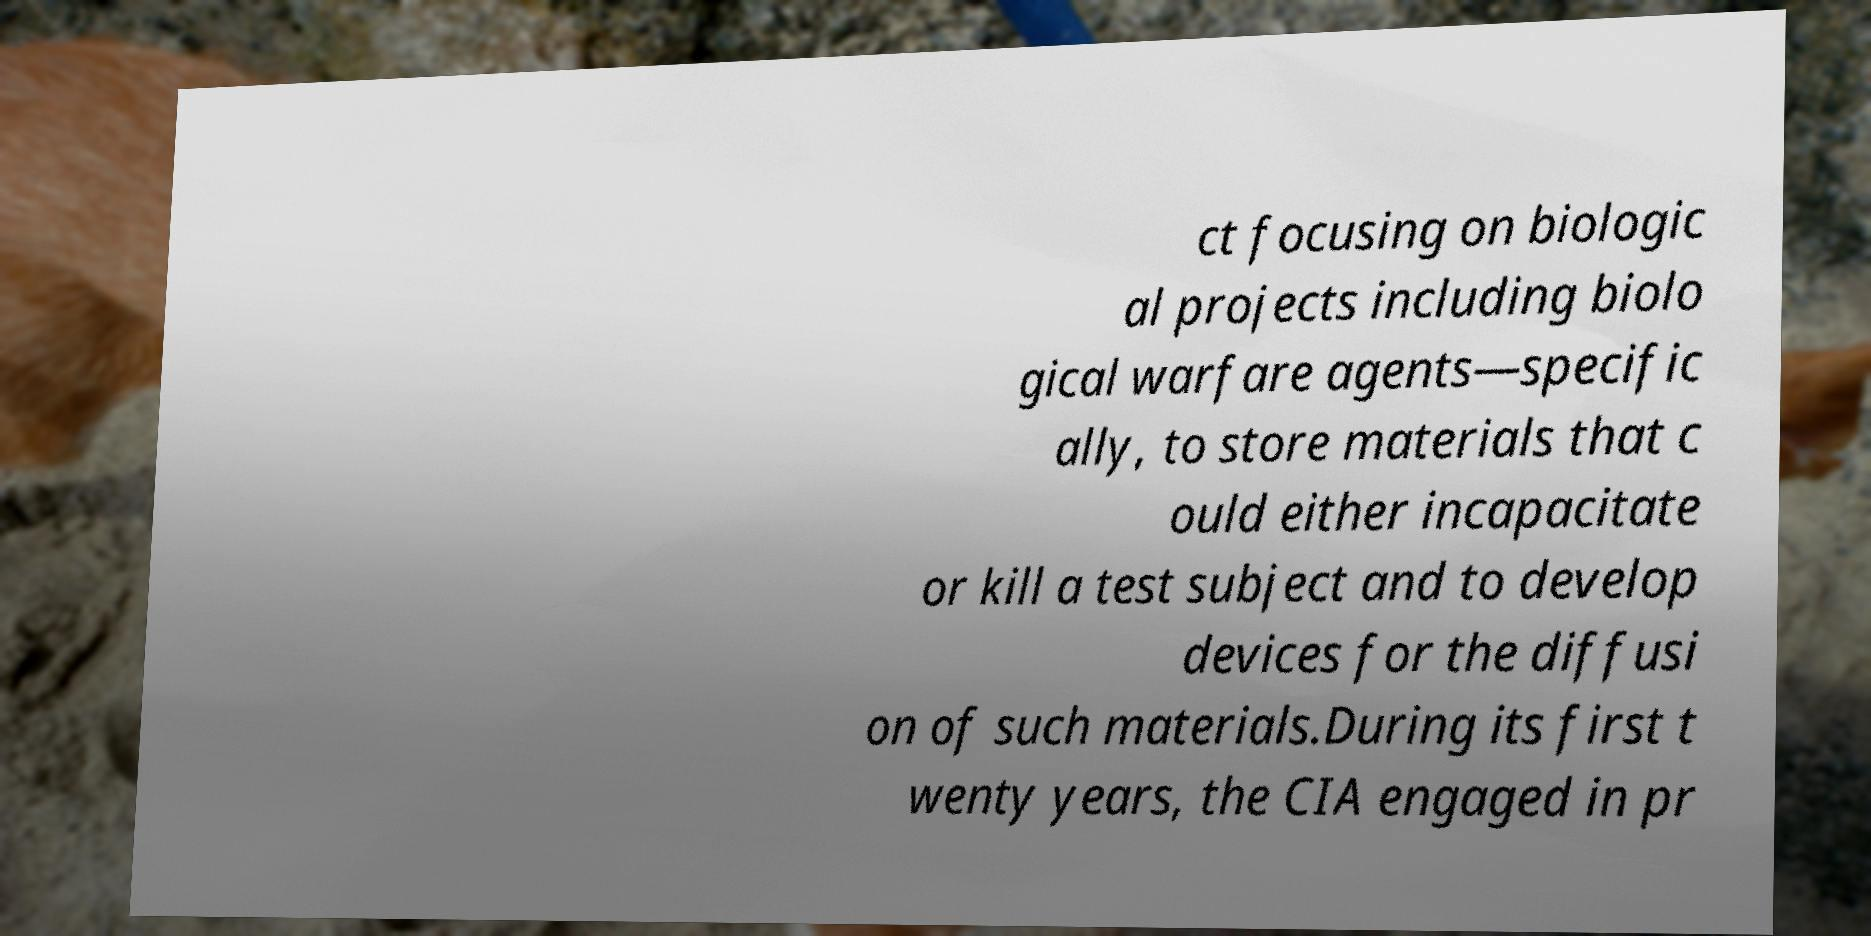Can you accurately transcribe the text from the provided image for me? ct focusing on biologic al projects including biolo gical warfare agents—specific ally, to store materials that c ould either incapacitate or kill a test subject and to develop devices for the diffusi on of such materials.During its first t wenty years, the CIA engaged in pr 